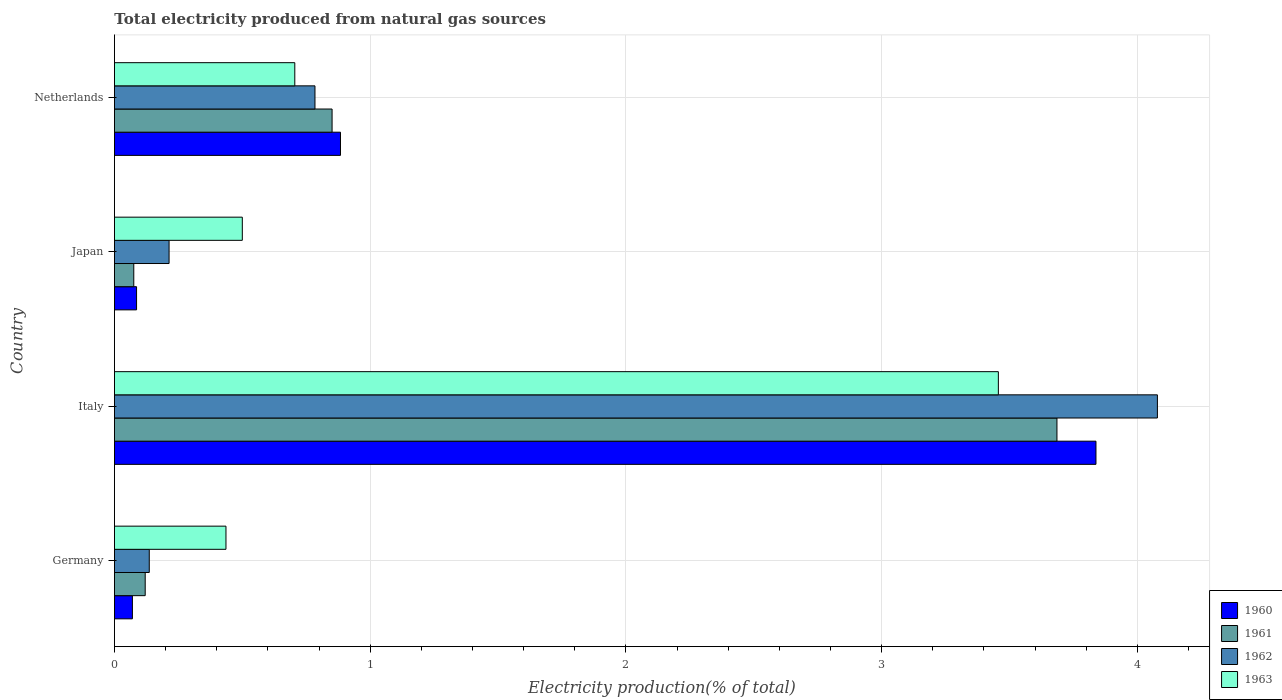How many groups of bars are there?
Provide a succinct answer. 4. Are the number of bars per tick equal to the number of legend labels?
Keep it short and to the point. Yes. How many bars are there on the 2nd tick from the bottom?
Make the answer very short. 4. What is the label of the 3rd group of bars from the top?
Provide a succinct answer. Italy. What is the total electricity produced in 1962 in Germany?
Your answer should be compact. 0.14. Across all countries, what is the maximum total electricity produced in 1962?
Give a very brief answer. 4.08. Across all countries, what is the minimum total electricity produced in 1961?
Provide a succinct answer. 0.08. In which country was the total electricity produced in 1962 maximum?
Make the answer very short. Italy. What is the total total electricity produced in 1962 in the graph?
Your answer should be compact. 5.21. What is the difference between the total electricity produced in 1960 in Italy and that in Japan?
Your answer should be very brief. 3.75. What is the difference between the total electricity produced in 1961 in Germany and the total electricity produced in 1962 in Netherlands?
Provide a succinct answer. -0.66. What is the average total electricity produced in 1962 per country?
Ensure brevity in your answer.  1.3. What is the difference between the total electricity produced in 1963 and total electricity produced in 1960 in Italy?
Your response must be concise. -0.38. What is the ratio of the total electricity produced in 1963 in Germany to that in Netherlands?
Your answer should be very brief. 0.62. Is the difference between the total electricity produced in 1963 in Italy and Japan greater than the difference between the total electricity produced in 1960 in Italy and Japan?
Your response must be concise. No. What is the difference between the highest and the second highest total electricity produced in 1960?
Give a very brief answer. 2.95. What is the difference between the highest and the lowest total electricity produced in 1962?
Your answer should be very brief. 3.94. Is it the case that in every country, the sum of the total electricity produced in 1960 and total electricity produced in 1962 is greater than the sum of total electricity produced in 1963 and total electricity produced in 1961?
Keep it short and to the point. No. Is it the case that in every country, the sum of the total electricity produced in 1963 and total electricity produced in 1962 is greater than the total electricity produced in 1961?
Your answer should be compact. Yes. Are the values on the major ticks of X-axis written in scientific E-notation?
Your answer should be compact. No. Does the graph contain any zero values?
Your response must be concise. No. Does the graph contain grids?
Offer a very short reply. Yes. Where does the legend appear in the graph?
Give a very brief answer. Bottom right. How many legend labels are there?
Provide a succinct answer. 4. What is the title of the graph?
Your answer should be compact. Total electricity produced from natural gas sources. What is the Electricity production(% of total) of 1960 in Germany?
Offer a very short reply. 0.07. What is the Electricity production(% of total) in 1961 in Germany?
Ensure brevity in your answer.  0.12. What is the Electricity production(% of total) in 1962 in Germany?
Offer a terse response. 0.14. What is the Electricity production(% of total) in 1963 in Germany?
Provide a short and direct response. 0.44. What is the Electricity production(% of total) in 1960 in Italy?
Your answer should be compact. 3.84. What is the Electricity production(% of total) in 1961 in Italy?
Offer a terse response. 3.69. What is the Electricity production(% of total) in 1962 in Italy?
Your answer should be very brief. 4.08. What is the Electricity production(% of total) of 1963 in Italy?
Provide a succinct answer. 3.46. What is the Electricity production(% of total) in 1960 in Japan?
Ensure brevity in your answer.  0.09. What is the Electricity production(% of total) of 1961 in Japan?
Offer a terse response. 0.08. What is the Electricity production(% of total) of 1962 in Japan?
Give a very brief answer. 0.21. What is the Electricity production(% of total) in 1963 in Japan?
Provide a short and direct response. 0.5. What is the Electricity production(% of total) of 1960 in Netherlands?
Offer a terse response. 0.88. What is the Electricity production(% of total) in 1961 in Netherlands?
Give a very brief answer. 0.85. What is the Electricity production(% of total) of 1962 in Netherlands?
Offer a terse response. 0.78. What is the Electricity production(% of total) in 1963 in Netherlands?
Ensure brevity in your answer.  0.71. Across all countries, what is the maximum Electricity production(% of total) of 1960?
Make the answer very short. 3.84. Across all countries, what is the maximum Electricity production(% of total) in 1961?
Your answer should be compact. 3.69. Across all countries, what is the maximum Electricity production(% of total) in 1962?
Ensure brevity in your answer.  4.08. Across all countries, what is the maximum Electricity production(% of total) in 1963?
Provide a short and direct response. 3.46. Across all countries, what is the minimum Electricity production(% of total) in 1960?
Your answer should be very brief. 0.07. Across all countries, what is the minimum Electricity production(% of total) in 1961?
Keep it short and to the point. 0.08. Across all countries, what is the minimum Electricity production(% of total) in 1962?
Ensure brevity in your answer.  0.14. Across all countries, what is the minimum Electricity production(% of total) in 1963?
Keep it short and to the point. 0.44. What is the total Electricity production(% of total) of 1960 in the graph?
Your answer should be compact. 4.88. What is the total Electricity production(% of total) of 1961 in the graph?
Your answer should be very brief. 4.73. What is the total Electricity production(% of total) in 1962 in the graph?
Your answer should be compact. 5.21. What is the total Electricity production(% of total) in 1963 in the graph?
Your answer should be very brief. 5.1. What is the difference between the Electricity production(% of total) in 1960 in Germany and that in Italy?
Provide a short and direct response. -3.77. What is the difference between the Electricity production(% of total) of 1961 in Germany and that in Italy?
Make the answer very short. -3.57. What is the difference between the Electricity production(% of total) in 1962 in Germany and that in Italy?
Ensure brevity in your answer.  -3.94. What is the difference between the Electricity production(% of total) of 1963 in Germany and that in Italy?
Provide a succinct answer. -3.02. What is the difference between the Electricity production(% of total) of 1960 in Germany and that in Japan?
Provide a succinct answer. -0.02. What is the difference between the Electricity production(% of total) in 1961 in Germany and that in Japan?
Keep it short and to the point. 0.04. What is the difference between the Electricity production(% of total) of 1962 in Germany and that in Japan?
Ensure brevity in your answer.  -0.08. What is the difference between the Electricity production(% of total) of 1963 in Germany and that in Japan?
Ensure brevity in your answer.  -0.06. What is the difference between the Electricity production(% of total) of 1960 in Germany and that in Netherlands?
Give a very brief answer. -0.81. What is the difference between the Electricity production(% of total) of 1961 in Germany and that in Netherlands?
Your response must be concise. -0.73. What is the difference between the Electricity production(% of total) in 1962 in Germany and that in Netherlands?
Keep it short and to the point. -0.65. What is the difference between the Electricity production(% of total) in 1963 in Germany and that in Netherlands?
Keep it short and to the point. -0.27. What is the difference between the Electricity production(% of total) of 1960 in Italy and that in Japan?
Offer a very short reply. 3.75. What is the difference between the Electricity production(% of total) of 1961 in Italy and that in Japan?
Offer a terse response. 3.61. What is the difference between the Electricity production(% of total) in 1962 in Italy and that in Japan?
Make the answer very short. 3.86. What is the difference between the Electricity production(% of total) of 1963 in Italy and that in Japan?
Give a very brief answer. 2.96. What is the difference between the Electricity production(% of total) of 1960 in Italy and that in Netherlands?
Provide a short and direct response. 2.95. What is the difference between the Electricity production(% of total) of 1961 in Italy and that in Netherlands?
Provide a short and direct response. 2.83. What is the difference between the Electricity production(% of total) of 1962 in Italy and that in Netherlands?
Provide a short and direct response. 3.29. What is the difference between the Electricity production(% of total) of 1963 in Italy and that in Netherlands?
Your response must be concise. 2.75. What is the difference between the Electricity production(% of total) of 1960 in Japan and that in Netherlands?
Offer a very short reply. -0.8. What is the difference between the Electricity production(% of total) of 1961 in Japan and that in Netherlands?
Make the answer very short. -0.78. What is the difference between the Electricity production(% of total) of 1962 in Japan and that in Netherlands?
Your answer should be compact. -0.57. What is the difference between the Electricity production(% of total) of 1963 in Japan and that in Netherlands?
Ensure brevity in your answer.  -0.21. What is the difference between the Electricity production(% of total) of 1960 in Germany and the Electricity production(% of total) of 1961 in Italy?
Provide a succinct answer. -3.62. What is the difference between the Electricity production(% of total) in 1960 in Germany and the Electricity production(% of total) in 1962 in Italy?
Provide a succinct answer. -4.01. What is the difference between the Electricity production(% of total) in 1960 in Germany and the Electricity production(% of total) in 1963 in Italy?
Make the answer very short. -3.39. What is the difference between the Electricity production(% of total) of 1961 in Germany and the Electricity production(% of total) of 1962 in Italy?
Provide a succinct answer. -3.96. What is the difference between the Electricity production(% of total) in 1961 in Germany and the Electricity production(% of total) in 1963 in Italy?
Give a very brief answer. -3.34. What is the difference between the Electricity production(% of total) of 1962 in Germany and the Electricity production(% of total) of 1963 in Italy?
Keep it short and to the point. -3.32. What is the difference between the Electricity production(% of total) of 1960 in Germany and the Electricity production(% of total) of 1961 in Japan?
Give a very brief answer. -0.01. What is the difference between the Electricity production(% of total) of 1960 in Germany and the Electricity production(% of total) of 1962 in Japan?
Ensure brevity in your answer.  -0.14. What is the difference between the Electricity production(% of total) of 1960 in Germany and the Electricity production(% of total) of 1963 in Japan?
Keep it short and to the point. -0.43. What is the difference between the Electricity production(% of total) of 1961 in Germany and the Electricity production(% of total) of 1962 in Japan?
Provide a short and direct response. -0.09. What is the difference between the Electricity production(% of total) of 1961 in Germany and the Electricity production(% of total) of 1963 in Japan?
Provide a short and direct response. -0.38. What is the difference between the Electricity production(% of total) in 1962 in Germany and the Electricity production(% of total) in 1963 in Japan?
Make the answer very short. -0.36. What is the difference between the Electricity production(% of total) of 1960 in Germany and the Electricity production(% of total) of 1961 in Netherlands?
Offer a terse response. -0.78. What is the difference between the Electricity production(% of total) of 1960 in Germany and the Electricity production(% of total) of 1962 in Netherlands?
Provide a short and direct response. -0.71. What is the difference between the Electricity production(% of total) of 1960 in Germany and the Electricity production(% of total) of 1963 in Netherlands?
Offer a terse response. -0.64. What is the difference between the Electricity production(% of total) in 1961 in Germany and the Electricity production(% of total) in 1962 in Netherlands?
Your answer should be very brief. -0.66. What is the difference between the Electricity production(% of total) in 1961 in Germany and the Electricity production(% of total) in 1963 in Netherlands?
Your answer should be very brief. -0.58. What is the difference between the Electricity production(% of total) of 1962 in Germany and the Electricity production(% of total) of 1963 in Netherlands?
Provide a succinct answer. -0.57. What is the difference between the Electricity production(% of total) of 1960 in Italy and the Electricity production(% of total) of 1961 in Japan?
Your answer should be very brief. 3.76. What is the difference between the Electricity production(% of total) of 1960 in Italy and the Electricity production(% of total) of 1962 in Japan?
Provide a short and direct response. 3.62. What is the difference between the Electricity production(% of total) of 1960 in Italy and the Electricity production(% of total) of 1963 in Japan?
Your answer should be very brief. 3.34. What is the difference between the Electricity production(% of total) of 1961 in Italy and the Electricity production(% of total) of 1962 in Japan?
Offer a very short reply. 3.47. What is the difference between the Electricity production(% of total) of 1961 in Italy and the Electricity production(% of total) of 1963 in Japan?
Your response must be concise. 3.19. What is the difference between the Electricity production(% of total) of 1962 in Italy and the Electricity production(% of total) of 1963 in Japan?
Your answer should be compact. 3.58. What is the difference between the Electricity production(% of total) of 1960 in Italy and the Electricity production(% of total) of 1961 in Netherlands?
Provide a succinct answer. 2.99. What is the difference between the Electricity production(% of total) in 1960 in Italy and the Electricity production(% of total) in 1962 in Netherlands?
Offer a very short reply. 3.05. What is the difference between the Electricity production(% of total) in 1960 in Italy and the Electricity production(% of total) in 1963 in Netherlands?
Your answer should be very brief. 3.13. What is the difference between the Electricity production(% of total) of 1961 in Italy and the Electricity production(% of total) of 1962 in Netherlands?
Make the answer very short. 2.9. What is the difference between the Electricity production(% of total) in 1961 in Italy and the Electricity production(% of total) in 1963 in Netherlands?
Your answer should be very brief. 2.98. What is the difference between the Electricity production(% of total) of 1962 in Italy and the Electricity production(% of total) of 1963 in Netherlands?
Your answer should be very brief. 3.37. What is the difference between the Electricity production(% of total) in 1960 in Japan and the Electricity production(% of total) in 1961 in Netherlands?
Your answer should be compact. -0.76. What is the difference between the Electricity production(% of total) of 1960 in Japan and the Electricity production(% of total) of 1962 in Netherlands?
Give a very brief answer. -0.7. What is the difference between the Electricity production(% of total) of 1960 in Japan and the Electricity production(% of total) of 1963 in Netherlands?
Ensure brevity in your answer.  -0.62. What is the difference between the Electricity production(% of total) of 1961 in Japan and the Electricity production(% of total) of 1962 in Netherlands?
Give a very brief answer. -0.71. What is the difference between the Electricity production(% of total) of 1961 in Japan and the Electricity production(% of total) of 1963 in Netherlands?
Make the answer very short. -0.63. What is the difference between the Electricity production(% of total) of 1962 in Japan and the Electricity production(% of total) of 1963 in Netherlands?
Make the answer very short. -0.49. What is the average Electricity production(% of total) of 1960 per country?
Make the answer very short. 1.22. What is the average Electricity production(% of total) of 1961 per country?
Make the answer very short. 1.18. What is the average Electricity production(% of total) in 1962 per country?
Offer a very short reply. 1.3. What is the average Electricity production(% of total) in 1963 per country?
Ensure brevity in your answer.  1.27. What is the difference between the Electricity production(% of total) in 1960 and Electricity production(% of total) in 1961 in Germany?
Your response must be concise. -0.05. What is the difference between the Electricity production(% of total) in 1960 and Electricity production(% of total) in 1962 in Germany?
Give a very brief answer. -0.07. What is the difference between the Electricity production(% of total) in 1960 and Electricity production(% of total) in 1963 in Germany?
Provide a short and direct response. -0.37. What is the difference between the Electricity production(% of total) of 1961 and Electricity production(% of total) of 1962 in Germany?
Your answer should be compact. -0.02. What is the difference between the Electricity production(% of total) of 1961 and Electricity production(% of total) of 1963 in Germany?
Ensure brevity in your answer.  -0.32. What is the difference between the Electricity production(% of total) of 1962 and Electricity production(% of total) of 1963 in Germany?
Your answer should be very brief. -0.3. What is the difference between the Electricity production(% of total) of 1960 and Electricity production(% of total) of 1961 in Italy?
Ensure brevity in your answer.  0.15. What is the difference between the Electricity production(% of total) of 1960 and Electricity production(% of total) of 1962 in Italy?
Your answer should be very brief. -0.24. What is the difference between the Electricity production(% of total) of 1960 and Electricity production(% of total) of 1963 in Italy?
Make the answer very short. 0.38. What is the difference between the Electricity production(% of total) in 1961 and Electricity production(% of total) in 1962 in Italy?
Give a very brief answer. -0.39. What is the difference between the Electricity production(% of total) in 1961 and Electricity production(% of total) in 1963 in Italy?
Provide a short and direct response. 0.23. What is the difference between the Electricity production(% of total) of 1962 and Electricity production(% of total) of 1963 in Italy?
Provide a short and direct response. 0.62. What is the difference between the Electricity production(% of total) of 1960 and Electricity production(% of total) of 1961 in Japan?
Keep it short and to the point. 0.01. What is the difference between the Electricity production(% of total) in 1960 and Electricity production(% of total) in 1962 in Japan?
Ensure brevity in your answer.  -0.13. What is the difference between the Electricity production(% of total) in 1960 and Electricity production(% of total) in 1963 in Japan?
Your response must be concise. -0.41. What is the difference between the Electricity production(% of total) in 1961 and Electricity production(% of total) in 1962 in Japan?
Make the answer very short. -0.14. What is the difference between the Electricity production(% of total) of 1961 and Electricity production(% of total) of 1963 in Japan?
Offer a terse response. -0.42. What is the difference between the Electricity production(% of total) in 1962 and Electricity production(% of total) in 1963 in Japan?
Give a very brief answer. -0.29. What is the difference between the Electricity production(% of total) of 1960 and Electricity production(% of total) of 1961 in Netherlands?
Ensure brevity in your answer.  0.03. What is the difference between the Electricity production(% of total) of 1960 and Electricity production(% of total) of 1962 in Netherlands?
Your answer should be very brief. 0.1. What is the difference between the Electricity production(% of total) of 1960 and Electricity production(% of total) of 1963 in Netherlands?
Provide a short and direct response. 0.18. What is the difference between the Electricity production(% of total) of 1961 and Electricity production(% of total) of 1962 in Netherlands?
Make the answer very short. 0.07. What is the difference between the Electricity production(% of total) of 1961 and Electricity production(% of total) of 1963 in Netherlands?
Your answer should be compact. 0.15. What is the difference between the Electricity production(% of total) in 1962 and Electricity production(% of total) in 1963 in Netherlands?
Provide a short and direct response. 0.08. What is the ratio of the Electricity production(% of total) of 1960 in Germany to that in Italy?
Make the answer very short. 0.02. What is the ratio of the Electricity production(% of total) in 1961 in Germany to that in Italy?
Your answer should be very brief. 0.03. What is the ratio of the Electricity production(% of total) of 1962 in Germany to that in Italy?
Offer a very short reply. 0.03. What is the ratio of the Electricity production(% of total) in 1963 in Germany to that in Italy?
Make the answer very short. 0.13. What is the ratio of the Electricity production(% of total) in 1960 in Germany to that in Japan?
Ensure brevity in your answer.  0.81. What is the ratio of the Electricity production(% of total) in 1961 in Germany to that in Japan?
Make the answer very short. 1.59. What is the ratio of the Electricity production(% of total) of 1962 in Germany to that in Japan?
Give a very brief answer. 0.64. What is the ratio of the Electricity production(% of total) of 1963 in Germany to that in Japan?
Offer a terse response. 0.87. What is the ratio of the Electricity production(% of total) in 1960 in Germany to that in Netherlands?
Keep it short and to the point. 0.08. What is the ratio of the Electricity production(% of total) in 1961 in Germany to that in Netherlands?
Your answer should be very brief. 0.14. What is the ratio of the Electricity production(% of total) in 1962 in Germany to that in Netherlands?
Give a very brief answer. 0.17. What is the ratio of the Electricity production(% of total) in 1963 in Germany to that in Netherlands?
Offer a terse response. 0.62. What is the ratio of the Electricity production(% of total) in 1960 in Italy to that in Japan?
Your response must be concise. 44.33. What is the ratio of the Electricity production(% of total) in 1961 in Italy to that in Japan?
Provide a short and direct response. 48.69. What is the ratio of the Electricity production(% of total) of 1962 in Italy to that in Japan?
Your response must be concise. 19.09. What is the ratio of the Electricity production(% of total) of 1963 in Italy to that in Japan?
Your response must be concise. 6.91. What is the ratio of the Electricity production(% of total) of 1960 in Italy to that in Netherlands?
Your response must be concise. 4.34. What is the ratio of the Electricity production(% of total) of 1961 in Italy to that in Netherlands?
Keep it short and to the point. 4.33. What is the ratio of the Electricity production(% of total) of 1962 in Italy to that in Netherlands?
Ensure brevity in your answer.  5.2. What is the ratio of the Electricity production(% of total) of 1963 in Italy to that in Netherlands?
Provide a short and direct response. 4.9. What is the ratio of the Electricity production(% of total) of 1960 in Japan to that in Netherlands?
Your answer should be compact. 0.1. What is the ratio of the Electricity production(% of total) in 1961 in Japan to that in Netherlands?
Give a very brief answer. 0.09. What is the ratio of the Electricity production(% of total) in 1962 in Japan to that in Netherlands?
Make the answer very short. 0.27. What is the ratio of the Electricity production(% of total) of 1963 in Japan to that in Netherlands?
Offer a very short reply. 0.71. What is the difference between the highest and the second highest Electricity production(% of total) in 1960?
Keep it short and to the point. 2.95. What is the difference between the highest and the second highest Electricity production(% of total) of 1961?
Keep it short and to the point. 2.83. What is the difference between the highest and the second highest Electricity production(% of total) of 1962?
Your response must be concise. 3.29. What is the difference between the highest and the second highest Electricity production(% of total) of 1963?
Make the answer very short. 2.75. What is the difference between the highest and the lowest Electricity production(% of total) of 1960?
Ensure brevity in your answer.  3.77. What is the difference between the highest and the lowest Electricity production(% of total) in 1961?
Your answer should be compact. 3.61. What is the difference between the highest and the lowest Electricity production(% of total) of 1962?
Your answer should be very brief. 3.94. What is the difference between the highest and the lowest Electricity production(% of total) of 1963?
Offer a very short reply. 3.02. 